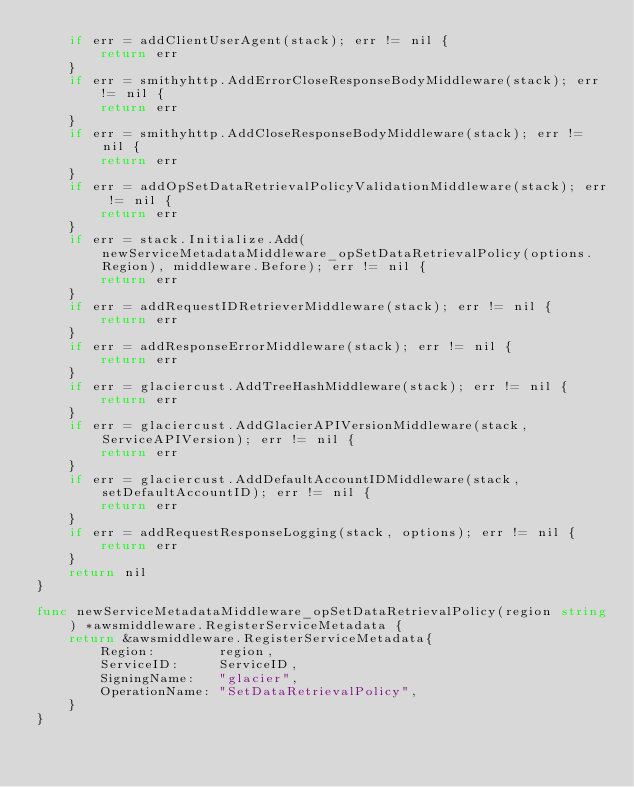Convert code to text. <code><loc_0><loc_0><loc_500><loc_500><_Go_>	if err = addClientUserAgent(stack); err != nil {
		return err
	}
	if err = smithyhttp.AddErrorCloseResponseBodyMiddleware(stack); err != nil {
		return err
	}
	if err = smithyhttp.AddCloseResponseBodyMiddleware(stack); err != nil {
		return err
	}
	if err = addOpSetDataRetrievalPolicyValidationMiddleware(stack); err != nil {
		return err
	}
	if err = stack.Initialize.Add(newServiceMetadataMiddleware_opSetDataRetrievalPolicy(options.Region), middleware.Before); err != nil {
		return err
	}
	if err = addRequestIDRetrieverMiddleware(stack); err != nil {
		return err
	}
	if err = addResponseErrorMiddleware(stack); err != nil {
		return err
	}
	if err = glaciercust.AddTreeHashMiddleware(stack); err != nil {
		return err
	}
	if err = glaciercust.AddGlacierAPIVersionMiddleware(stack, ServiceAPIVersion); err != nil {
		return err
	}
	if err = glaciercust.AddDefaultAccountIDMiddleware(stack, setDefaultAccountID); err != nil {
		return err
	}
	if err = addRequestResponseLogging(stack, options); err != nil {
		return err
	}
	return nil
}

func newServiceMetadataMiddleware_opSetDataRetrievalPolicy(region string) *awsmiddleware.RegisterServiceMetadata {
	return &awsmiddleware.RegisterServiceMetadata{
		Region:        region,
		ServiceID:     ServiceID,
		SigningName:   "glacier",
		OperationName: "SetDataRetrievalPolicy",
	}
}
</code> 